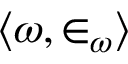<formula> <loc_0><loc_0><loc_500><loc_500>\langle \omega , \in _ { \omega } \rangle</formula> 